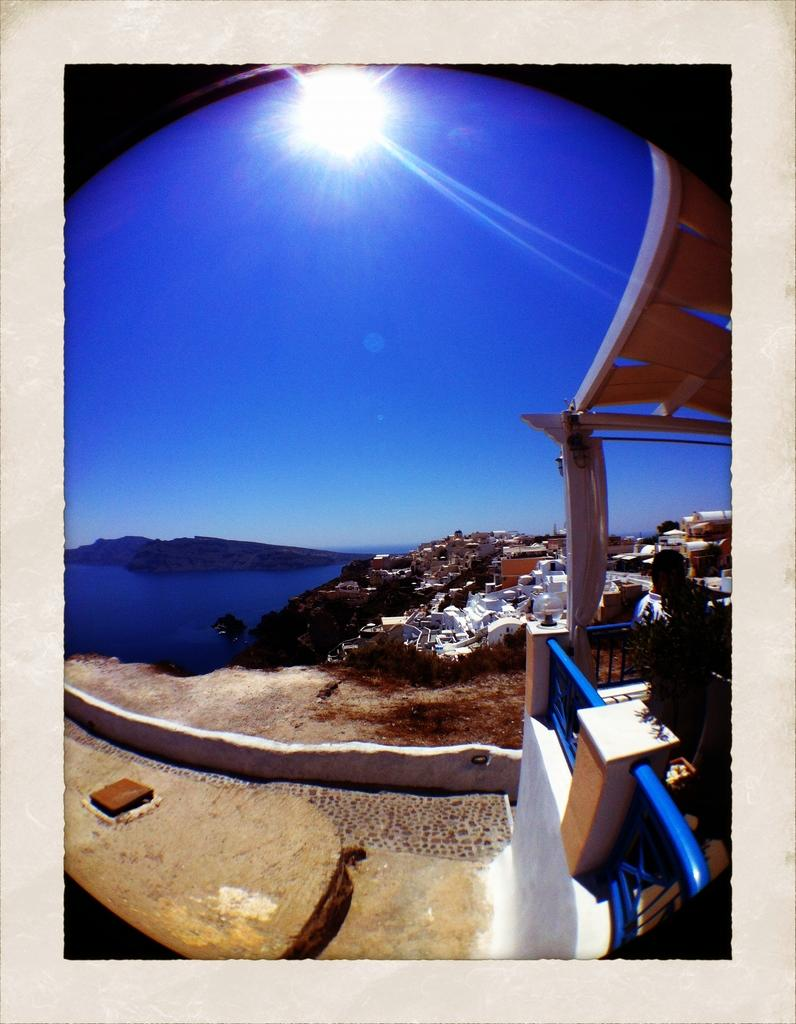What type of structures are located on the right side of the image? There are buildings on the right side of the image. What is present on the left side of the image? There is water on the left side of the image. What can be seen in the background of the image? The sun and sky are visible in the background of the image. How many bats are flying in the image? There are no bats present in the image. What type of clouds can be seen in the image? There are no clouds mentioned in the provided facts, and the image does not show any clouds. 